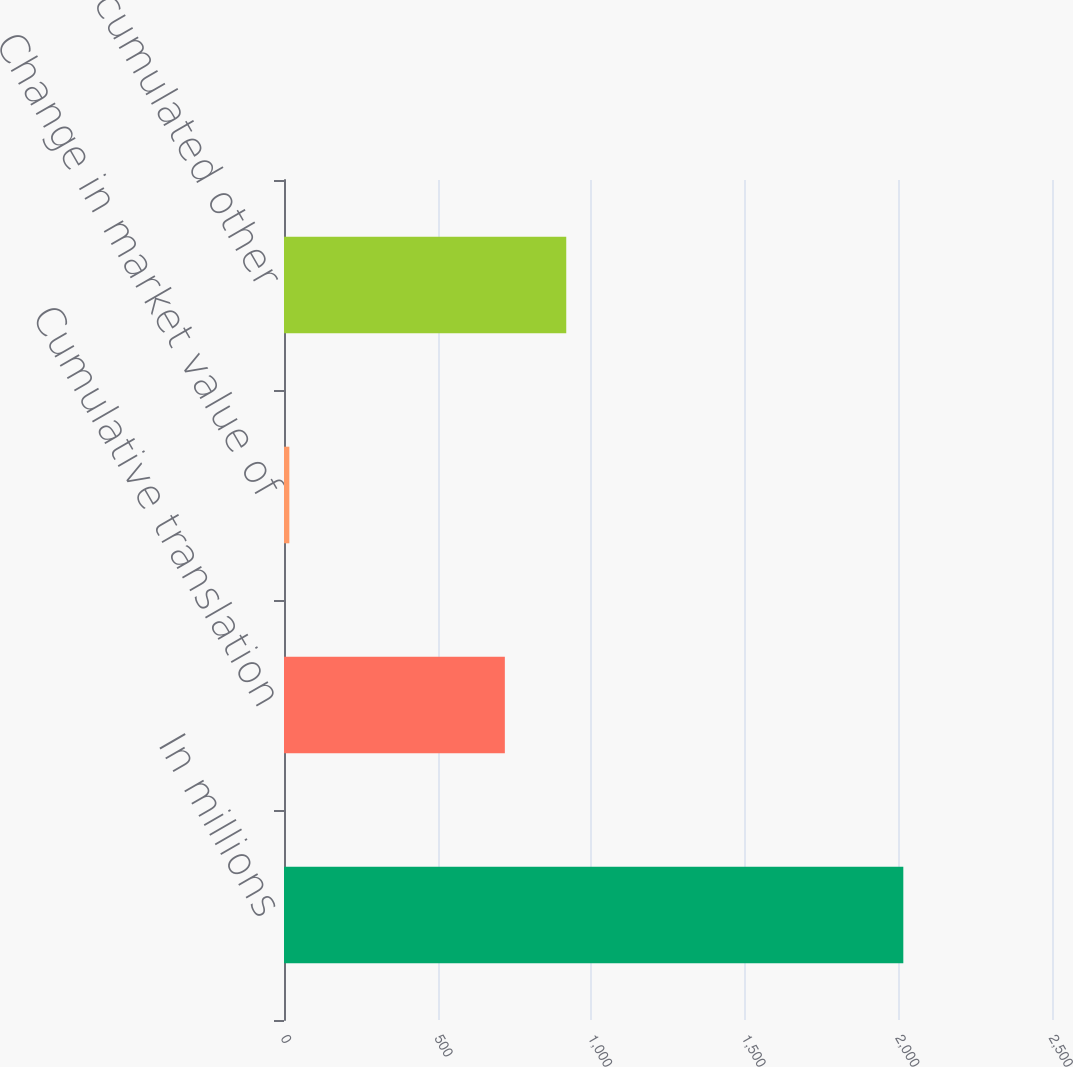<chart> <loc_0><loc_0><loc_500><loc_500><bar_chart><fcel>In millions<fcel>Cumulative translation<fcel>Change in market value of<fcel>Accumulated other<nl><fcel>2016<fcel>718.9<fcel>17.4<fcel>918.76<nl></chart> 